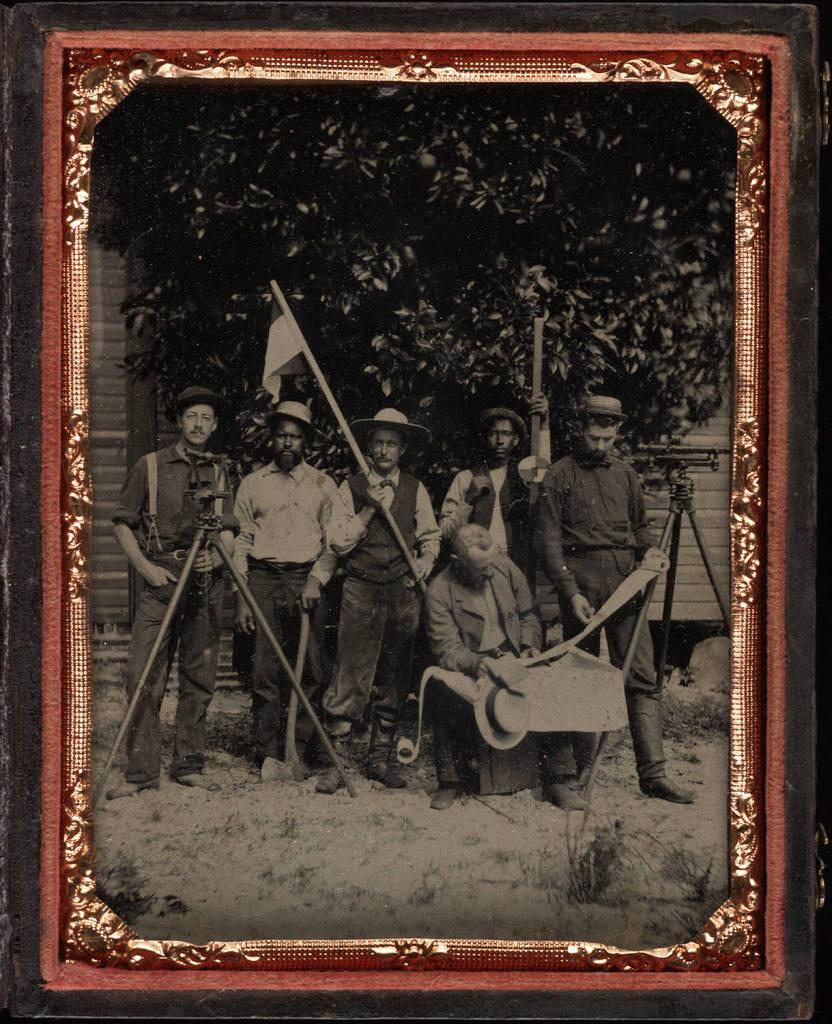What object is the main focus of the image? There is a photo frame in the image. What is depicted inside the photo frame? The photo frame contains a picture of people on the ground. What can be seen in the background of the image? There is a wall and trees in the background of the image. What is the price of the mailbox in the image? There is no mailbox present in the image. What type of building can be seen in the background of the image? The image does not show any buildings in the background; it only features a wall and trees. 